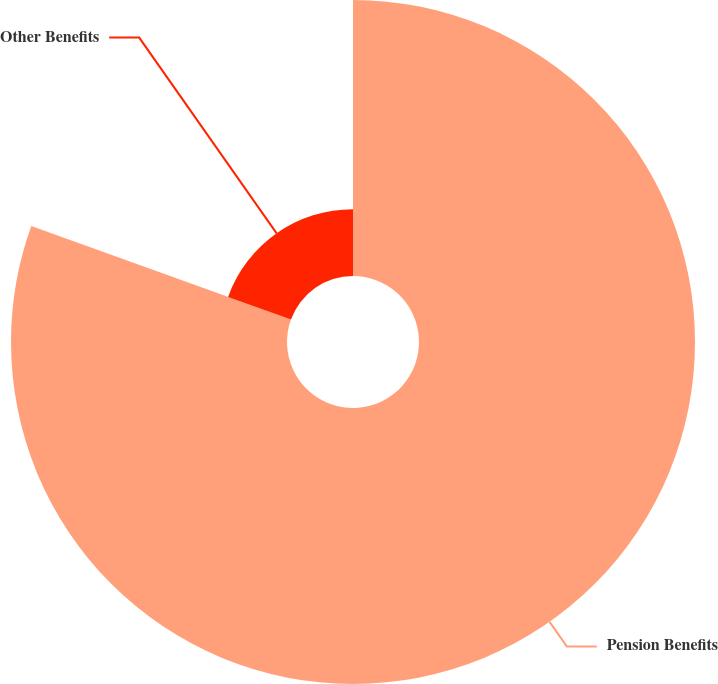<chart> <loc_0><loc_0><loc_500><loc_500><pie_chart><fcel>Pension Benefits<fcel>Other Benefits<nl><fcel>80.51%<fcel>19.49%<nl></chart> 